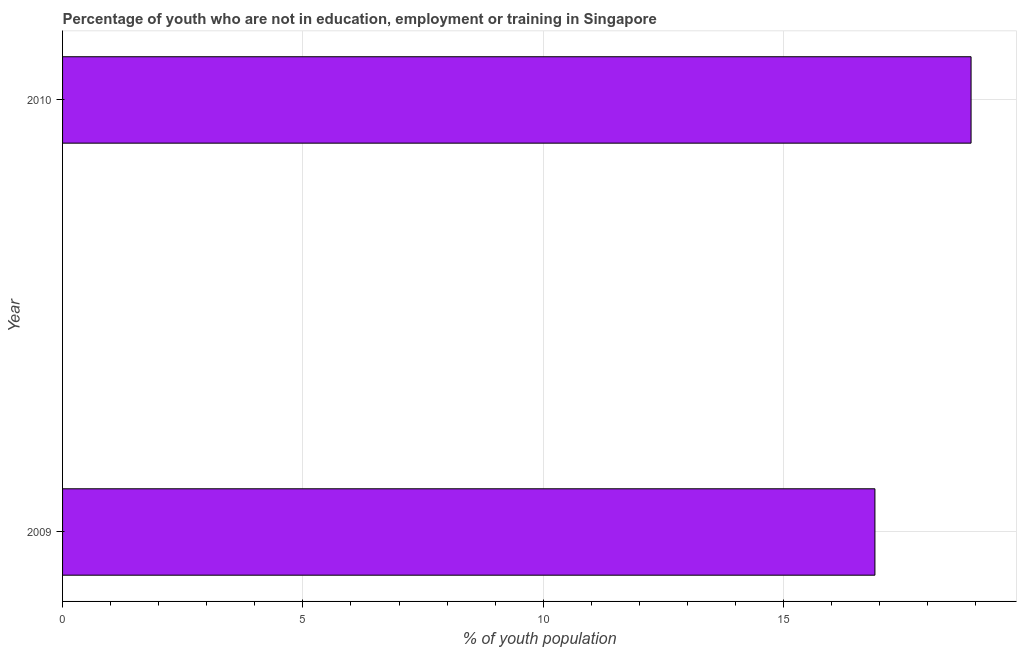Does the graph contain any zero values?
Your response must be concise. No. Does the graph contain grids?
Provide a succinct answer. Yes. What is the title of the graph?
Give a very brief answer. Percentage of youth who are not in education, employment or training in Singapore. What is the label or title of the X-axis?
Keep it short and to the point. % of youth population. What is the unemployed youth population in 2009?
Your answer should be compact. 16.9. Across all years, what is the maximum unemployed youth population?
Offer a very short reply. 18.9. Across all years, what is the minimum unemployed youth population?
Make the answer very short. 16.9. In which year was the unemployed youth population maximum?
Give a very brief answer. 2010. In which year was the unemployed youth population minimum?
Ensure brevity in your answer.  2009. What is the sum of the unemployed youth population?
Provide a short and direct response. 35.8. What is the median unemployed youth population?
Your answer should be compact. 17.9. In how many years, is the unemployed youth population greater than 8 %?
Make the answer very short. 2. What is the ratio of the unemployed youth population in 2009 to that in 2010?
Offer a very short reply. 0.89. Is the unemployed youth population in 2009 less than that in 2010?
Offer a terse response. Yes. In how many years, is the unemployed youth population greater than the average unemployed youth population taken over all years?
Make the answer very short. 1. Are all the bars in the graph horizontal?
Offer a very short reply. Yes. Are the values on the major ticks of X-axis written in scientific E-notation?
Keep it short and to the point. No. What is the % of youth population in 2009?
Your answer should be very brief. 16.9. What is the % of youth population in 2010?
Your answer should be very brief. 18.9. What is the ratio of the % of youth population in 2009 to that in 2010?
Provide a succinct answer. 0.89. 